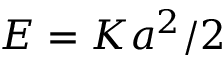<formula> <loc_0><loc_0><loc_500><loc_500>E = K a ^ { 2 } / 2</formula> 